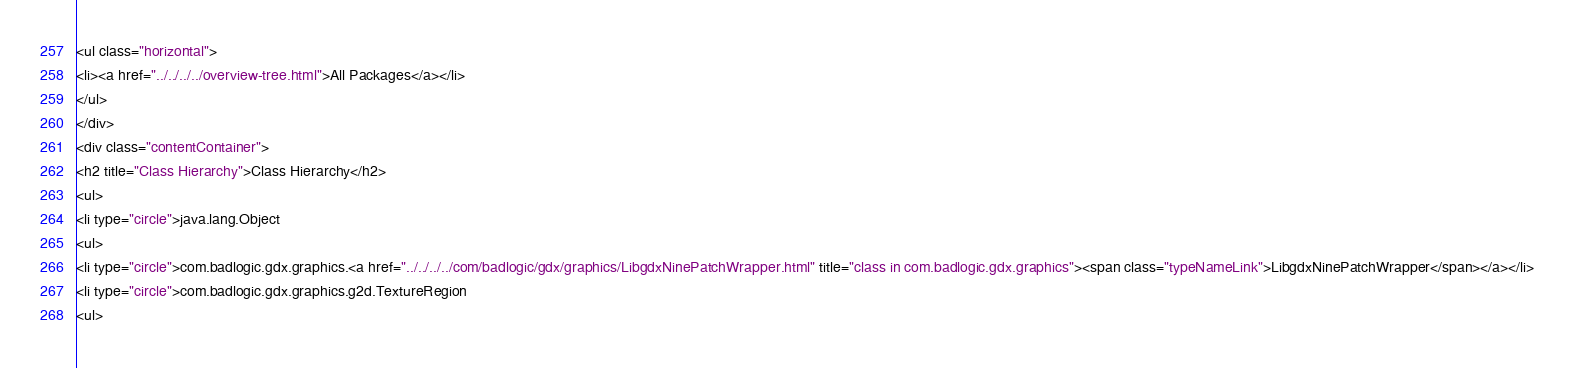<code> <loc_0><loc_0><loc_500><loc_500><_HTML_><ul class="horizontal">
<li><a href="../../../../overview-tree.html">All Packages</a></li>
</ul>
</div>
<div class="contentContainer">
<h2 title="Class Hierarchy">Class Hierarchy</h2>
<ul>
<li type="circle">java.lang.Object
<ul>
<li type="circle">com.badlogic.gdx.graphics.<a href="../../../../com/badlogic/gdx/graphics/LibgdxNinePatchWrapper.html" title="class in com.badlogic.gdx.graphics"><span class="typeNameLink">LibgdxNinePatchWrapper</span></a></li>
<li type="circle">com.badlogic.gdx.graphics.g2d.TextureRegion
<ul></code> 